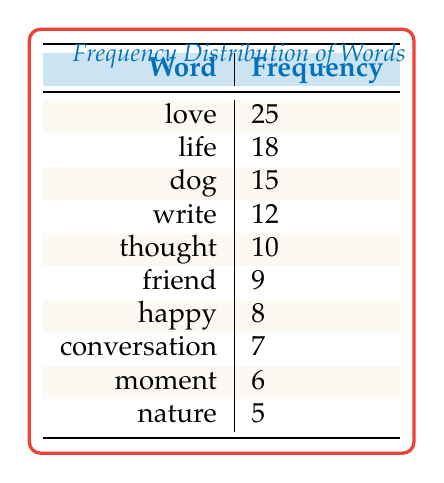What is the frequency of the word "love"? The frequency of the word "love" is directly stated in the table under the corresponding row, which shows a frequency of 25.
Answer: 25 Which word appears most frequently in the writing samples? By looking at the table, we can see that "love" has the highest frequency of 25 compared to other words listed.
Answer: love How many times is the word "dog" mentioned compared to "nature"? The table shows "dog" with a frequency of 15 and "nature" with a frequency of 5. To find the difference, we subtract: 15 - 5 = 10.
Answer: 10 What is the total frequency of the five least common words in the table? The five least common words are "friend" (9), "happy" (8), "conversation" (7), "moment" (6), and "nature" (5). Summing these gives: 9 + 8 + 7 + 6 + 5 = 35.
Answer: 35 Is the frequency of the word "thought" greater than the frequency of "friend"? The table shows "thought" has a frequency of 10 while "friend" has 9. Since 10 is greater than 9, the statement is true.
Answer: Yes What is the average frequency of the words listed in the table? To find the average, we first sum all frequencies: 25 + 18 + 15 + 12 + 10 + 9 + 8 + 7 + 6 + 5 =  115. There are 10 words, so we divide: 115 / 10 = 11.5.
Answer: 11.5 Which word has a frequency closest to the median frequency of the words listed? To find the median, we first list the frequencies in order: 5, 6, 7, 8, 9, 10, 12, 15, 18, 25. The median of these 10 values (even number of items) is the average of the 5th and 6th values: (9 + 10) / 2 = 9.5. The word "friend" (9) is the closest to this median.
Answer: friend How many words have a frequency of 10 or more? From the table, we look at the frequencies: 25, 18, 15, 12, and 10, which gives us a total of 5 words that meet this criterion.
Answer: 5 Is "happy" the least common word in the table? In the table, "happy" has a frequency of 8, while "nature" has a frequency of 5, which is lower than that of "happy". Thus, "happy" is not the least common word.
Answer: No 